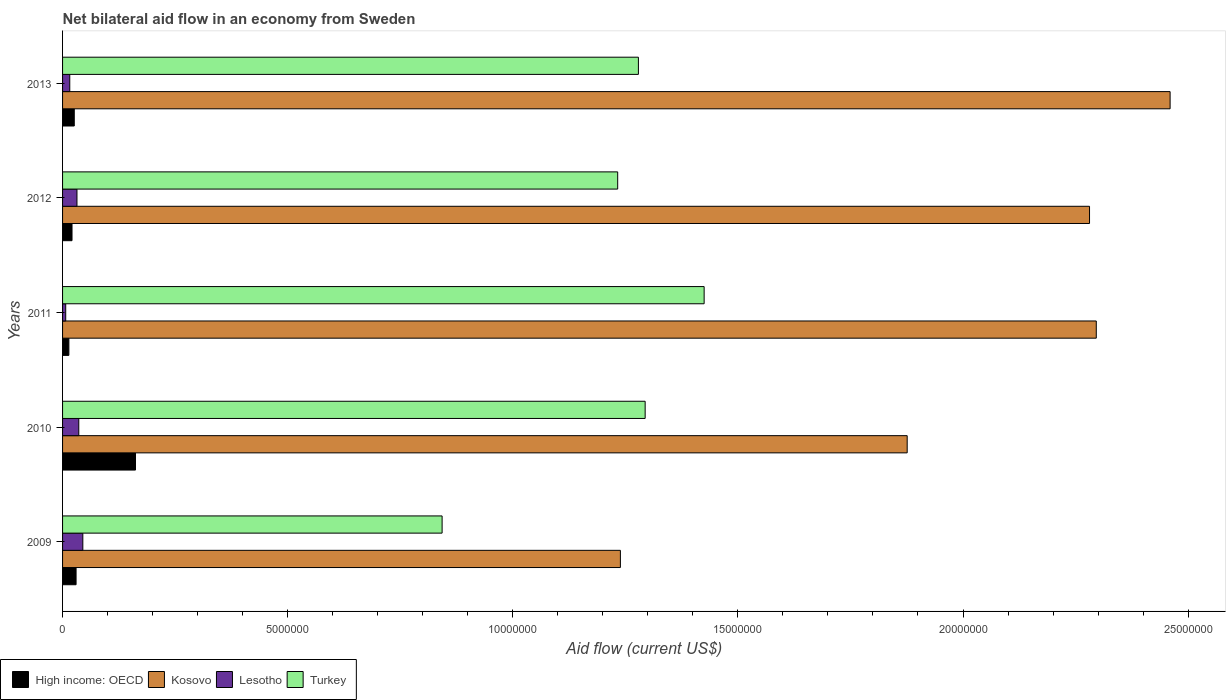How many different coloured bars are there?
Give a very brief answer. 4. Are the number of bars per tick equal to the number of legend labels?
Give a very brief answer. Yes. Are the number of bars on each tick of the Y-axis equal?
Your answer should be compact. Yes. How many bars are there on the 5th tick from the bottom?
Your answer should be very brief. 4. In how many cases, is the number of bars for a given year not equal to the number of legend labels?
Offer a terse response. 0. Across all years, what is the maximum net bilateral aid flow in Lesotho?
Your answer should be very brief. 4.50e+05. In which year was the net bilateral aid flow in Kosovo maximum?
Offer a very short reply. 2013. In which year was the net bilateral aid flow in High income: OECD minimum?
Make the answer very short. 2011. What is the total net bilateral aid flow in High income: OECD in the graph?
Provide a succinct answer. 2.53e+06. What is the difference between the net bilateral aid flow in Kosovo in 2013 and the net bilateral aid flow in Turkey in 2012?
Offer a terse response. 1.23e+07. What is the average net bilateral aid flow in Kosovo per year?
Offer a very short reply. 2.03e+07. In the year 2013, what is the difference between the net bilateral aid flow in High income: OECD and net bilateral aid flow in Kosovo?
Give a very brief answer. -2.43e+07. In how many years, is the net bilateral aid flow in Kosovo greater than 3000000 US$?
Give a very brief answer. 5. What is the ratio of the net bilateral aid flow in Turkey in 2009 to that in 2012?
Offer a very short reply. 0.68. Is the difference between the net bilateral aid flow in High income: OECD in 2010 and 2012 greater than the difference between the net bilateral aid flow in Kosovo in 2010 and 2012?
Your answer should be compact. Yes. What is the difference between the highest and the lowest net bilateral aid flow in Lesotho?
Provide a succinct answer. 3.80e+05. Is it the case that in every year, the sum of the net bilateral aid flow in Lesotho and net bilateral aid flow in High income: OECD is greater than the sum of net bilateral aid flow in Turkey and net bilateral aid flow in Kosovo?
Your response must be concise. No. What does the 2nd bar from the bottom in 2013 represents?
Provide a short and direct response. Kosovo. Are all the bars in the graph horizontal?
Your answer should be very brief. Yes. How many years are there in the graph?
Give a very brief answer. 5. Are the values on the major ticks of X-axis written in scientific E-notation?
Ensure brevity in your answer.  No. Where does the legend appear in the graph?
Give a very brief answer. Bottom left. How are the legend labels stacked?
Provide a short and direct response. Horizontal. What is the title of the graph?
Provide a short and direct response. Net bilateral aid flow in an economy from Sweden. Does "Togo" appear as one of the legend labels in the graph?
Your answer should be very brief. No. What is the Aid flow (current US$) in High income: OECD in 2009?
Your answer should be compact. 3.00e+05. What is the Aid flow (current US$) in Kosovo in 2009?
Make the answer very short. 1.24e+07. What is the Aid flow (current US$) in Turkey in 2009?
Your response must be concise. 8.43e+06. What is the Aid flow (current US$) in High income: OECD in 2010?
Offer a terse response. 1.62e+06. What is the Aid flow (current US$) in Kosovo in 2010?
Offer a terse response. 1.88e+07. What is the Aid flow (current US$) in Turkey in 2010?
Offer a terse response. 1.29e+07. What is the Aid flow (current US$) in High income: OECD in 2011?
Make the answer very short. 1.40e+05. What is the Aid flow (current US$) of Kosovo in 2011?
Provide a short and direct response. 2.30e+07. What is the Aid flow (current US$) in Turkey in 2011?
Provide a short and direct response. 1.42e+07. What is the Aid flow (current US$) of Kosovo in 2012?
Ensure brevity in your answer.  2.28e+07. What is the Aid flow (current US$) of Turkey in 2012?
Your response must be concise. 1.23e+07. What is the Aid flow (current US$) of Kosovo in 2013?
Provide a succinct answer. 2.46e+07. What is the Aid flow (current US$) of Turkey in 2013?
Keep it short and to the point. 1.28e+07. Across all years, what is the maximum Aid flow (current US$) in High income: OECD?
Offer a terse response. 1.62e+06. Across all years, what is the maximum Aid flow (current US$) in Kosovo?
Offer a terse response. 2.46e+07. Across all years, what is the maximum Aid flow (current US$) in Turkey?
Give a very brief answer. 1.42e+07. Across all years, what is the minimum Aid flow (current US$) of Kosovo?
Ensure brevity in your answer.  1.24e+07. Across all years, what is the minimum Aid flow (current US$) in Lesotho?
Your answer should be very brief. 7.00e+04. Across all years, what is the minimum Aid flow (current US$) in Turkey?
Ensure brevity in your answer.  8.43e+06. What is the total Aid flow (current US$) in High income: OECD in the graph?
Make the answer very short. 2.53e+06. What is the total Aid flow (current US$) of Kosovo in the graph?
Your answer should be compact. 1.02e+08. What is the total Aid flow (current US$) of Lesotho in the graph?
Ensure brevity in your answer.  1.36e+06. What is the total Aid flow (current US$) of Turkey in the graph?
Offer a very short reply. 6.07e+07. What is the difference between the Aid flow (current US$) in High income: OECD in 2009 and that in 2010?
Give a very brief answer. -1.32e+06. What is the difference between the Aid flow (current US$) in Kosovo in 2009 and that in 2010?
Offer a terse response. -6.37e+06. What is the difference between the Aid flow (current US$) of Lesotho in 2009 and that in 2010?
Keep it short and to the point. 9.00e+04. What is the difference between the Aid flow (current US$) in Turkey in 2009 and that in 2010?
Make the answer very short. -4.51e+06. What is the difference between the Aid flow (current US$) in Kosovo in 2009 and that in 2011?
Your answer should be compact. -1.06e+07. What is the difference between the Aid flow (current US$) of Turkey in 2009 and that in 2011?
Give a very brief answer. -5.82e+06. What is the difference between the Aid flow (current US$) in High income: OECD in 2009 and that in 2012?
Your response must be concise. 9.00e+04. What is the difference between the Aid flow (current US$) of Kosovo in 2009 and that in 2012?
Ensure brevity in your answer.  -1.04e+07. What is the difference between the Aid flow (current US$) in Turkey in 2009 and that in 2012?
Provide a succinct answer. -3.90e+06. What is the difference between the Aid flow (current US$) in High income: OECD in 2009 and that in 2013?
Ensure brevity in your answer.  4.00e+04. What is the difference between the Aid flow (current US$) in Kosovo in 2009 and that in 2013?
Offer a terse response. -1.22e+07. What is the difference between the Aid flow (current US$) of Lesotho in 2009 and that in 2013?
Your answer should be compact. 2.90e+05. What is the difference between the Aid flow (current US$) of Turkey in 2009 and that in 2013?
Provide a succinct answer. -4.36e+06. What is the difference between the Aid flow (current US$) in High income: OECD in 2010 and that in 2011?
Ensure brevity in your answer.  1.48e+06. What is the difference between the Aid flow (current US$) of Kosovo in 2010 and that in 2011?
Provide a short and direct response. -4.20e+06. What is the difference between the Aid flow (current US$) of Turkey in 2010 and that in 2011?
Your response must be concise. -1.31e+06. What is the difference between the Aid flow (current US$) in High income: OECD in 2010 and that in 2012?
Give a very brief answer. 1.41e+06. What is the difference between the Aid flow (current US$) in Kosovo in 2010 and that in 2012?
Give a very brief answer. -4.05e+06. What is the difference between the Aid flow (current US$) in Turkey in 2010 and that in 2012?
Your response must be concise. 6.10e+05. What is the difference between the Aid flow (current US$) in High income: OECD in 2010 and that in 2013?
Provide a short and direct response. 1.36e+06. What is the difference between the Aid flow (current US$) of Kosovo in 2010 and that in 2013?
Your answer should be compact. -5.84e+06. What is the difference between the Aid flow (current US$) of Turkey in 2011 and that in 2012?
Give a very brief answer. 1.92e+06. What is the difference between the Aid flow (current US$) in High income: OECD in 2011 and that in 2013?
Make the answer very short. -1.20e+05. What is the difference between the Aid flow (current US$) of Kosovo in 2011 and that in 2013?
Your answer should be very brief. -1.64e+06. What is the difference between the Aid flow (current US$) of Lesotho in 2011 and that in 2013?
Give a very brief answer. -9.00e+04. What is the difference between the Aid flow (current US$) of Turkey in 2011 and that in 2013?
Give a very brief answer. 1.46e+06. What is the difference between the Aid flow (current US$) in Kosovo in 2012 and that in 2013?
Provide a short and direct response. -1.79e+06. What is the difference between the Aid flow (current US$) of Turkey in 2012 and that in 2013?
Offer a very short reply. -4.60e+05. What is the difference between the Aid flow (current US$) of High income: OECD in 2009 and the Aid flow (current US$) of Kosovo in 2010?
Offer a very short reply. -1.85e+07. What is the difference between the Aid flow (current US$) in High income: OECD in 2009 and the Aid flow (current US$) in Lesotho in 2010?
Provide a succinct answer. -6.00e+04. What is the difference between the Aid flow (current US$) in High income: OECD in 2009 and the Aid flow (current US$) in Turkey in 2010?
Give a very brief answer. -1.26e+07. What is the difference between the Aid flow (current US$) in Kosovo in 2009 and the Aid flow (current US$) in Lesotho in 2010?
Make the answer very short. 1.20e+07. What is the difference between the Aid flow (current US$) in Kosovo in 2009 and the Aid flow (current US$) in Turkey in 2010?
Offer a very short reply. -5.50e+05. What is the difference between the Aid flow (current US$) in Lesotho in 2009 and the Aid flow (current US$) in Turkey in 2010?
Keep it short and to the point. -1.25e+07. What is the difference between the Aid flow (current US$) in High income: OECD in 2009 and the Aid flow (current US$) in Kosovo in 2011?
Make the answer very short. -2.27e+07. What is the difference between the Aid flow (current US$) of High income: OECD in 2009 and the Aid flow (current US$) of Lesotho in 2011?
Offer a terse response. 2.30e+05. What is the difference between the Aid flow (current US$) in High income: OECD in 2009 and the Aid flow (current US$) in Turkey in 2011?
Your response must be concise. -1.40e+07. What is the difference between the Aid flow (current US$) in Kosovo in 2009 and the Aid flow (current US$) in Lesotho in 2011?
Your answer should be compact. 1.23e+07. What is the difference between the Aid flow (current US$) in Kosovo in 2009 and the Aid flow (current US$) in Turkey in 2011?
Offer a terse response. -1.86e+06. What is the difference between the Aid flow (current US$) in Lesotho in 2009 and the Aid flow (current US$) in Turkey in 2011?
Offer a very short reply. -1.38e+07. What is the difference between the Aid flow (current US$) in High income: OECD in 2009 and the Aid flow (current US$) in Kosovo in 2012?
Ensure brevity in your answer.  -2.25e+07. What is the difference between the Aid flow (current US$) in High income: OECD in 2009 and the Aid flow (current US$) in Turkey in 2012?
Give a very brief answer. -1.20e+07. What is the difference between the Aid flow (current US$) in Kosovo in 2009 and the Aid flow (current US$) in Lesotho in 2012?
Your answer should be very brief. 1.21e+07. What is the difference between the Aid flow (current US$) in Lesotho in 2009 and the Aid flow (current US$) in Turkey in 2012?
Ensure brevity in your answer.  -1.19e+07. What is the difference between the Aid flow (current US$) of High income: OECD in 2009 and the Aid flow (current US$) of Kosovo in 2013?
Provide a short and direct response. -2.43e+07. What is the difference between the Aid flow (current US$) in High income: OECD in 2009 and the Aid flow (current US$) in Turkey in 2013?
Your answer should be compact. -1.25e+07. What is the difference between the Aid flow (current US$) of Kosovo in 2009 and the Aid flow (current US$) of Lesotho in 2013?
Provide a succinct answer. 1.22e+07. What is the difference between the Aid flow (current US$) of Kosovo in 2009 and the Aid flow (current US$) of Turkey in 2013?
Provide a short and direct response. -4.00e+05. What is the difference between the Aid flow (current US$) in Lesotho in 2009 and the Aid flow (current US$) in Turkey in 2013?
Provide a succinct answer. -1.23e+07. What is the difference between the Aid flow (current US$) in High income: OECD in 2010 and the Aid flow (current US$) in Kosovo in 2011?
Ensure brevity in your answer.  -2.13e+07. What is the difference between the Aid flow (current US$) of High income: OECD in 2010 and the Aid flow (current US$) of Lesotho in 2011?
Offer a terse response. 1.55e+06. What is the difference between the Aid flow (current US$) in High income: OECD in 2010 and the Aid flow (current US$) in Turkey in 2011?
Offer a very short reply. -1.26e+07. What is the difference between the Aid flow (current US$) of Kosovo in 2010 and the Aid flow (current US$) of Lesotho in 2011?
Ensure brevity in your answer.  1.87e+07. What is the difference between the Aid flow (current US$) of Kosovo in 2010 and the Aid flow (current US$) of Turkey in 2011?
Your response must be concise. 4.51e+06. What is the difference between the Aid flow (current US$) of Lesotho in 2010 and the Aid flow (current US$) of Turkey in 2011?
Ensure brevity in your answer.  -1.39e+07. What is the difference between the Aid flow (current US$) of High income: OECD in 2010 and the Aid flow (current US$) of Kosovo in 2012?
Provide a succinct answer. -2.12e+07. What is the difference between the Aid flow (current US$) of High income: OECD in 2010 and the Aid flow (current US$) of Lesotho in 2012?
Offer a terse response. 1.30e+06. What is the difference between the Aid flow (current US$) in High income: OECD in 2010 and the Aid flow (current US$) in Turkey in 2012?
Make the answer very short. -1.07e+07. What is the difference between the Aid flow (current US$) in Kosovo in 2010 and the Aid flow (current US$) in Lesotho in 2012?
Your answer should be very brief. 1.84e+07. What is the difference between the Aid flow (current US$) in Kosovo in 2010 and the Aid flow (current US$) in Turkey in 2012?
Give a very brief answer. 6.43e+06. What is the difference between the Aid flow (current US$) in Lesotho in 2010 and the Aid flow (current US$) in Turkey in 2012?
Offer a terse response. -1.20e+07. What is the difference between the Aid flow (current US$) in High income: OECD in 2010 and the Aid flow (current US$) in Kosovo in 2013?
Provide a short and direct response. -2.30e+07. What is the difference between the Aid flow (current US$) in High income: OECD in 2010 and the Aid flow (current US$) in Lesotho in 2013?
Provide a short and direct response. 1.46e+06. What is the difference between the Aid flow (current US$) in High income: OECD in 2010 and the Aid flow (current US$) in Turkey in 2013?
Offer a very short reply. -1.12e+07. What is the difference between the Aid flow (current US$) of Kosovo in 2010 and the Aid flow (current US$) of Lesotho in 2013?
Your answer should be very brief. 1.86e+07. What is the difference between the Aid flow (current US$) of Kosovo in 2010 and the Aid flow (current US$) of Turkey in 2013?
Make the answer very short. 5.97e+06. What is the difference between the Aid flow (current US$) in Lesotho in 2010 and the Aid flow (current US$) in Turkey in 2013?
Your answer should be very brief. -1.24e+07. What is the difference between the Aid flow (current US$) in High income: OECD in 2011 and the Aid flow (current US$) in Kosovo in 2012?
Offer a very short reply. -2.27e+07. What is the difference between the Aid flow (current US$) in High income: OECD in 2011 and the Aid flow (current US$) in Lesotho in 2012?
Offer a very short reply. -1.80e+05. What is the difference between the Aid flow (current US$) in High income: OECD in 2011 and the Aid flow (current US$) in Turkey in 2012?
Offer a terse response. -1.22e+07. What is the difference between the Aid flow (current US$) of Kosovo in 2011 and the Aid flow (current US$) of Lesotho in 2012?
Your response must be concise. 2.26e+07. What is the difference between the Aid flow (current US$) of Kosovo in 2011 and the Aid flow (current US$) of Turkey in 2012?
Your answer should be very brief. 1.06e+07. What is the difference between the Aid flow (current US$) of Lesotho in 2011 and the Aid flow (current US$) of Turkey in 2012?
Offer a terse response. -1.23e+07. What is the difference between the Aid flow (current US$) in High income: OECD in 2011 and the Aid flow (current US$) in Kosovo in 2013?
Offer a very short reply. -2.45e+07. What is the difference between the Aid flow (current US$) in High income: OECD in 2011 and the Aid flow (current US$) in Lesotho in 2013?
Provide a succinct answer. -2.00e+04. What is the difference between the Aid flow (current US$) in High income: OECD in 2011 and the Aid flow (current US$) in Turkey in 2013?
Offer a very short reply. -1.26e+07. What is the difference between the Aid flow (current US$) of Kosovo in 2011 and the Aid flow (current US$) of Lesotho in 2013?
Provide a succinct answer. 2.28e+07. What is the difference between the Aid flow (current US$) in Kosovo in 2011 and the Aid flow (current US$) in Turkey in 2013?
Ensure brevity in your answer.  1.02e+07. What is the difference between the Aid flow (current US$) of Lesotho in 2011 and the Aid flow (current US$) of Turkey in 2013?
Give a very brief answer. -1.27e+07. What is the difference between the Aid flow (current US$) of High income: OECD in 2012 and the Aid flow (current US$) of Kosovo in 2013?
Give a very brief answer. -2.44e+07. What is the difference between the Aid flow (current US$) of High income: OECD in 2012 and the Aid flow (current US$) of Turkey in 2013?
Offer a terse response. -1.26e+07. What is the difference between the Aid flow (current US$) of Kosovo in 2012 and the Aid flow (current US$) of Lesotho in 2013?
Provide a succinct answer. 2.26e+07. What is the difference between the Aid flow (current US$) in Kosovo in 2012 and the Aid flow (current US$) in Turkey in 2013?
Give a very brief answer. 1.00e+07. What is the difference between the Aid flow (current US$) of Lesotho in 2012 and the Aid flow (current US$) of Turkey in 2013?
Offer a very short reply. -1.25e+07. What is the average Aid flow (current US$) of High income: OECD per year?
Give a very brief answer. 5.06e+05. What is the average Aid flow (current US$) in Kosovo per year?
Your answer should be compact. 2.03e+07. What is the average Aid flow (current US$) in Lesotho per year?
Make the answer very short. 2.72e+05. What is the average Aid flow (current US$) in Turkey per year?
Your answer should be compact. 1.21e+07. In the year 2009, what is the difference between the Aid flow (current US$) of High income: OECD and Aid flow (current US$) of Kosovo?
Offer a terse response. -1.21e+07. In the year 2009, what is the difference between the Aid flow (current US$) in High income: OECD and Aid flow (current US$) in Lesotho?
Give a very brief answer. -1.50e+05. In the year 2009, what is the difference between the Aid flow (current US$) of High income: OECD and Aid flow (current US$) of Turkey?
Provide a short and direct response. -8.13e+06. In the year 2009, what is the difference between the Aid flow (current US$) of Kosovo and Aid flow (current US$) of Lesotho?
Offer a very short reply. 1.19e+07. In the year 2009, what is the difference between the Aid flow (current US$) in Kosovo and Aid flow (current US$) in Turkey?
Your answer should be very brief. 3.96e+06. In the year 2009, what is the difference between the Aid flow (current US$) in Lesotho and Aid flow (current US$) in Turkey?
Your response must be concise. -7.98e+06. In the year 2010, what is the difference between the Aid flow (current US$) in High income: OECD and Aid flow (current US$) in Kosovo?
Your answer should be compact. -1.71e+07. In the year 2010, what is the difference between the Aid flow (current US$) of High income: OECD and Aid flow (current US$) of Lesotho?
Make the answer very short. 1.26e+06. In the year 2010, what is the difference between the Aid flow (current US$) of High income: OECD and Aid flow (current US$) of Turkey?
Offer a very short reply. -1.13e+07. In the year 2010, what is the difference between the Aid flow (current US$) in Kosovo and Aid flow (current US$) in Lesotho?
Give a very brief answer. 1.84e+07. In the year 2010, what is the difference between the Aid flow (current US$) of Kosovo and Aid flow (current US$) of Turkey?
Make the answer very short. 5.82e+06. In the year 2010, what is the difference between the Aid flow (current US$) in Lesotho and Aid flow (current US$) in Turkey?
Provide a succinct answer. -1.26e+07. In the year 2011, what is the difference between the Aid flow (current US$) of High income: OECD and Aid flow (current US$) of Kosovo?
Keep it short and to the point. -2.28e+07. In the year 2011, what is the difference between the Aid flow (current US$) of High income: OECD and Aid flow (current US$) of Lesotho?
Your answer should be compact. 7.00e+04. In the year 2011, what is the difference between the Aid flow (current US$) in High income: OECD and Aid flow (current US$) in Turkey?
Provide a short and direct response. -1.41e+07. In the year 2011, what is the difference between the Aid flow (current US$) in Kosovo and Aid flow (current US$) in Lesotho?
Your response must be concise. 2.29e+07. In the year 2011, what is the difference between the Aid flow (current US$) in Kosovo and Aid flow (current US$) in Turkey?
Make the answer very short. 8.71e+06. In the year 2011, what is the difference between the Aid flow (current US$) of Lesotho and Aid flow (current US$) of Turkey?
Provide a short and direct response. -1.42e+07. In the year 2012, what is the difference between the Aid flow (current US$) in High income: OECD and Aid flow (current US$) in Kosovo?
Provide a succinct answer. -2.26e+07. In the year 2012, what is the difference between the Aid flow (current US$) of High income: OECD and Aid flow (current US$) of Turkey?
Provide a succinct answer. -1.21e+07. In the year 2012, what is the difference between the Aid flow (current US$) of Kosovo and Aid flow (current US$) of Lesotho?
Give a very brief answer. 2.25e+07. In the year 2012, what is the difference between the Aid flow (current US$) in Kosovo and Aid flow (current US$) in Turkey?
Your response must be concise. 1.05e+07. In the year 2012, what is the difference between the Aid flow (current US$) in Lesotho and Aid flow (current US$) in Turkey?
Ensure brevity in your answer.  -1.20e+07. In the year 2013, what is the difference between the Aid flow (current US$) in High income: OECD and Aid flow (current US$) in Kosovo?
Ensure brevity in your answer.  -2.43e+07. In the year 2013, what is the difference between the Aid flow (current US$) in High income: OECD and Aid flow (current US$) in Lesotho?
Your answer should be compact. 1.00e+05. In the year 2013, what is the difference between the Aid flow (current US$) of High income: OECD and Aid flow (current US$) of Turkey?
Provide a short and direct response. -1.25e+07. In the year 2013, what is the difference between the Aid flow (current US$) in Kosovo and Aid flow (current US$) in Lesotho?
Give a very brief answer. 2.44e+07. In the year 2013, what is the difference between the Aid flow (current US$) in Kosovo and Aid flow (current US$) in Turkey?
Make the answer very short. 1.18e+07. In the year 2013, what is the difference between the Aid flow (current US$) in Lesotho and Aid flow (current US$) in Turkey?
Offer a terse response. -1.26e+07. What is the ratio of the Aid flow (current US$) of High income: OECD in 2009 to that in 2010?
Offer a terse response. 0.19. What is the ratio of the Aid flow (current US$) in Kosovo in 2009 to that in 2010?
Keep it short and to the point. 0.66. What is the ratio of the Aid flow (current US$) of Lesotho in 2009 to that in 2010?
Give a very brief answer. 1.25. What is the ratio of the Aid flow (current US$) in Turkey in 2009 to that in 2010?
Offer a terse response. 0.65. What is the ratio of the Aid flow (current US$) in High income: OECD in 2009 to that in 2011?
Provide a succinct answer. 2.14. What is the ratio of the Aid flow (current US$) of Kosovo in 2009 to that in 2011?
Provide a succinct answer. 0.54. What is the ratio of the Aid flow (current US$) in Lesotho in 2009 to that in 2011?
Offer a very short reply. 6.43. What is the ratio of the Aid flow (current US$) in Turkey in 2009 to that in 2011?
Offer a very short reply. 0.59. What is the ratio of the Aid flow (current US$) of High income: OECD in 2009 to that in 2012?
Keep it short and to the point. 1.43. What is the ratio of the Aid flow (current US$) in Kosovo in 2009 to that in 2012?
Provide a short and direct response. 0.54. What is the ratio of the Aid flow (current US$) of Lesotho in 2009 to that in 2012?
Offer a terse response. 1.41. What is the ratio of the Aid flow (current US$) of Turkey in 2009 to that in 2012?
Ensure brevity in your answer.  0.68. What is the ratio of the Aid flow (current US$) of High income: OECD in 2009 to that in 2013?
Your answer should be very brief. 1.15. What is the ratio of the Aid flow (current US$) in Kosovo in 2009 to that in 2013?
Ensure brevity in your answer.  0.5. What is the ratio of the Aid flow (current US$) in Lesotho in 2009 to that in 2013?
Keep it short and to the point. 2.81. What is the ratio of the Aid flow (current US$) in Turkey in 2009 to that in 2013?
Offer a very short reply. 0.66. What is the ratio of the Aid flow (current US$) in High income: OECD in 2010 to that in 2011?
Your response must be concise. 11.57. What is the ratio of the Aid flow (current US$) of Kosovo in 2010 to that in 2011?
Your answer should be compact. 0.82. What is the ratio of the Aid flow (current US$) of Lesotho in 2010 to that in 2011?
Provide a short and direct response. 5.14. What is the ratio of the Aid flow (current US$) in Turkey in 2010 to that in 2011?
Keep it short and to the point. 0.91. What is the ratio of the Aid flow (current US$) of High income: OECD in 2010 to that in 2012?
Provide a succinct answer. 7.71. What is the ratio of the Aid flow (current US$) in Kosovo in 2010 to that in 2012?
Provide a succinct answer. 0.82. What is the ratio of the Aid flow (current US$) in Turkey in 2010 to that in 2012?
Offer a terse response. 1.05. What is the ratio of the Aid flow (current US$) in High income: OECD in 2010 to that in 2013?
Your response must be concise. 6.23. What is the ratio of the Aid flow (current US$) in Kosovo in 2010 to that in 2013?
Your response must be concise. 0.76. What is the ratio of the Aid flow (current US$) of Lesotho in 2010 to that in 2013?
Keep it short and to the point. 2.25. What is the ratio of the Aid flow (current US$) in Turkey in 2010 to that in 2013?
Ensure brevity in your answer.  1.01. What is the ratio of the Aid flow (current US$) of Kosovo in 2011 to that in 2012?
Offer a very short reply. 1.01. What is the ratio of the Aid flow (current US$) in Lesotho in 2011 to that in 2012?
Offer a terse response. 0.22. What is the ratio of the Aid flow (current US$) in Turkey in 2011 to that in 2012?
Offer a very short reply. 1.16. What is the ratio of the Aid flow (current US$) in High income: OECD in 2011 to that in 2013?
Offer a terse response. 0.54. What is the ratio of the Aid flow (current US$) of Kosovo in 2011 to that in 2013?
Your answer should be very brief. 0.93. What is the ratio of the Aid flow (current US$) of Lesotho in 2011 to that in 2013?
Offer a very short reply. 0.44. What is the ratio of the Aid flow (current US$) in Turkey in 2011 to that in 2013?
Your response must be concise. 1.11. What is the ratio of the Aid flow (current US$) in High income: OECD in 2012 to that in 2013?
Make the answer very short. 0.81. What is the ratio of the Aid flow (current US$) of Kosovo in 2012 to that in 2013?
Give a very brief answer. 0.93. What is the ratio of the Aid flow (current US$) in Turkey in 2012 to that in 2013?
Offer a terse response. 0.96. What is the difference between the highest and the second highest Aid flow (current US$) of High income: OECD?
Ensure brevity in your answer.  1.32e+06. What is the difference between the highest and the second highest Aid flow (current US$) of Kosovo?
Provide a short and direct response. 1.64e+06. What is the difference between the highest and the second highest Aid flow (current US$) of Turkey?
Keep it short and to the point. 1.31e+06. What is the difference between the highest and the lowest Aid flow (current US$) in High income: OECD?
Your answer should be very brief. 1.48e+06. What is the difference between the highest and the lowest Aid flow (current US$) in Kosovo?
Your answer should be compact. 1.22e+07. What is the difference between the highest and the lowest Aid flow (current US$) in Turkey?
Offer a very short reply. 5.82e+06. 